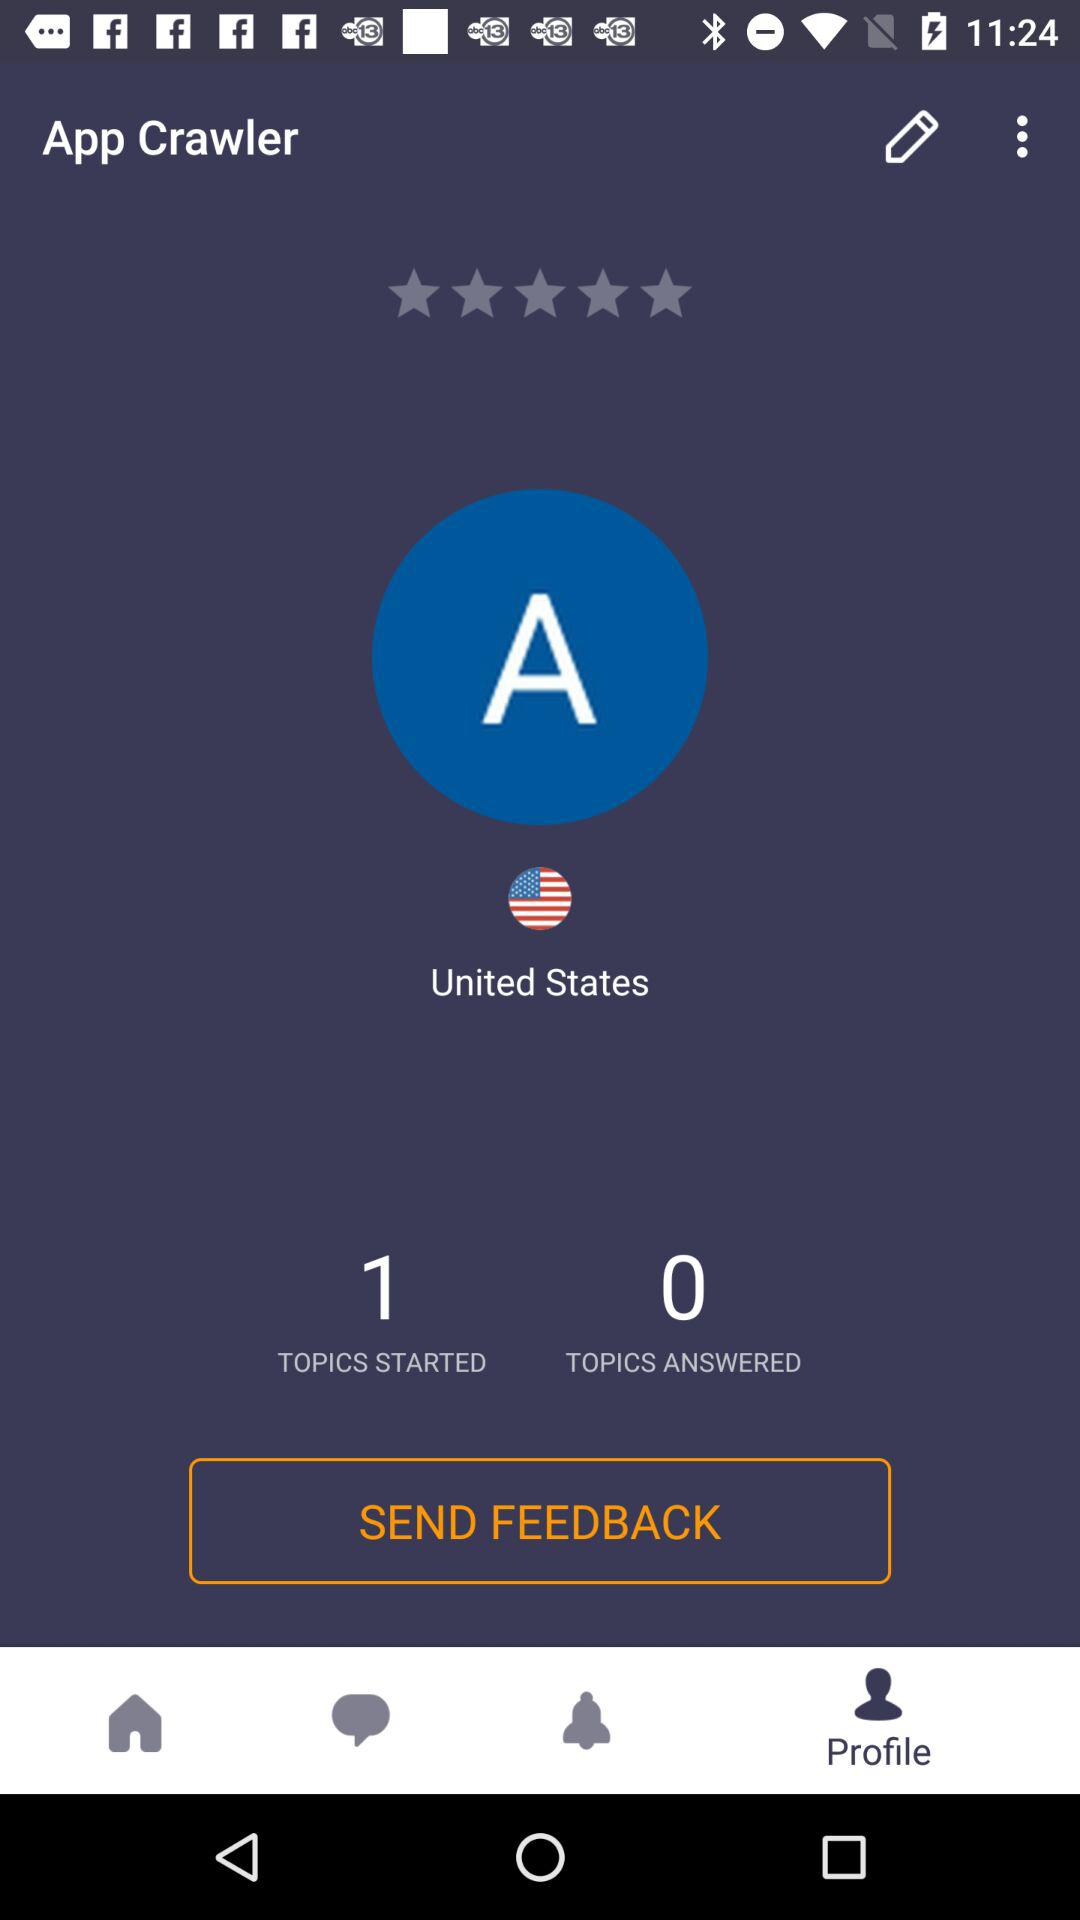What is the user name? The user name is "App Crawler". 